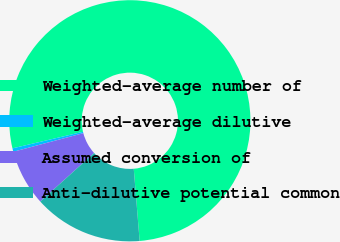Convert chart. <chart><loc_0><loc_0><loc_500><loc_500><pie_chart><fcel>Weighted-average number of<fcel>Weighted-average dilutive<fcel>Assumed conversion of<fcel>Anti-dilutive potential common<nl><fcel>77.38%<fcel>0.46%<fcel>7.54%<fcel>14.62%<nl></chart> 